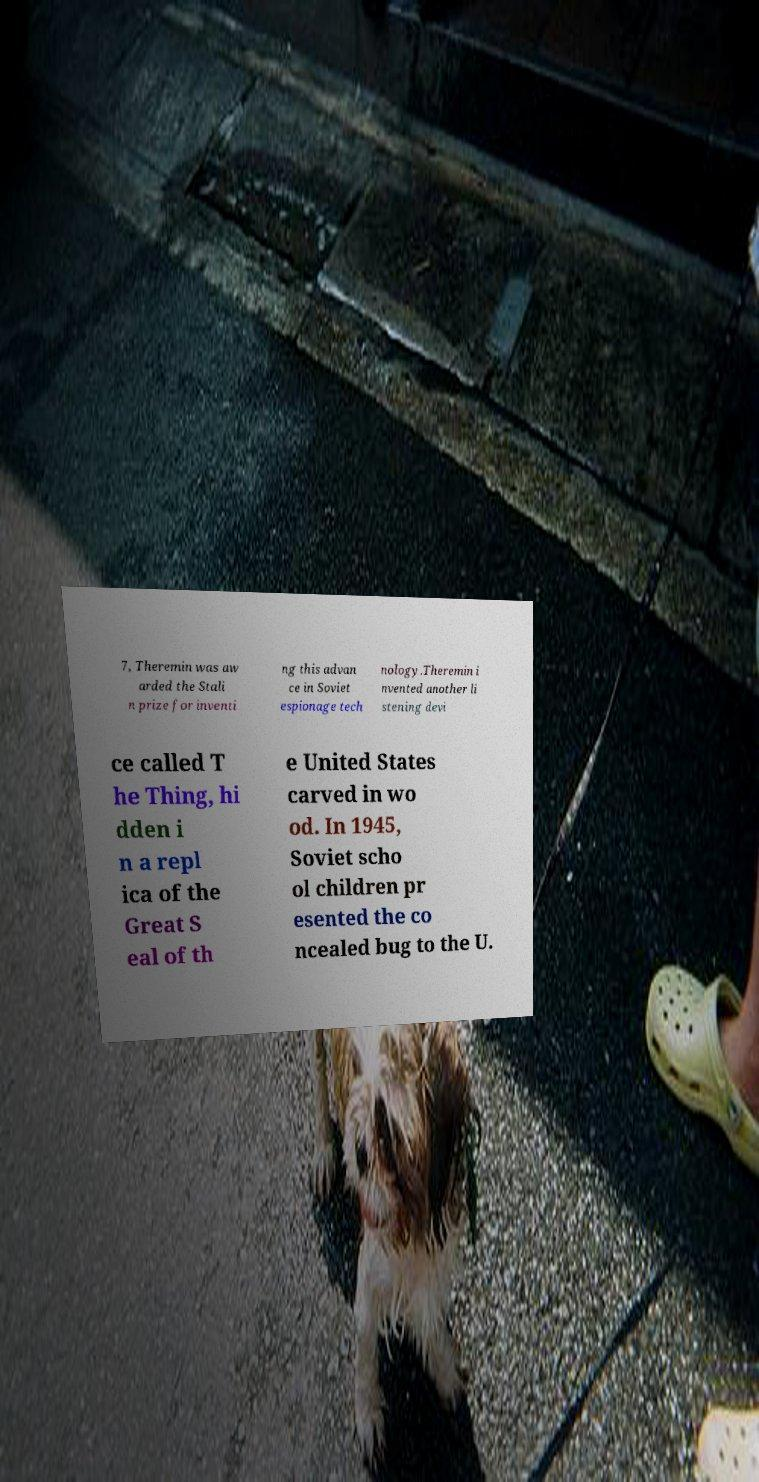Can you accurately transcribe the text from the provided image for me? 7, Theremin was aw arded the Stali n prize for inventi ng this advan ce in Soviet espionage tech nology.Theremin i nvented another li stening devi ce called T he Thing, hi dden i n a repl ica of the Great S eal of th e United States carved in wo od. In 1945, Soviet scho ol children pr esented the co ncealed bug to the U. 